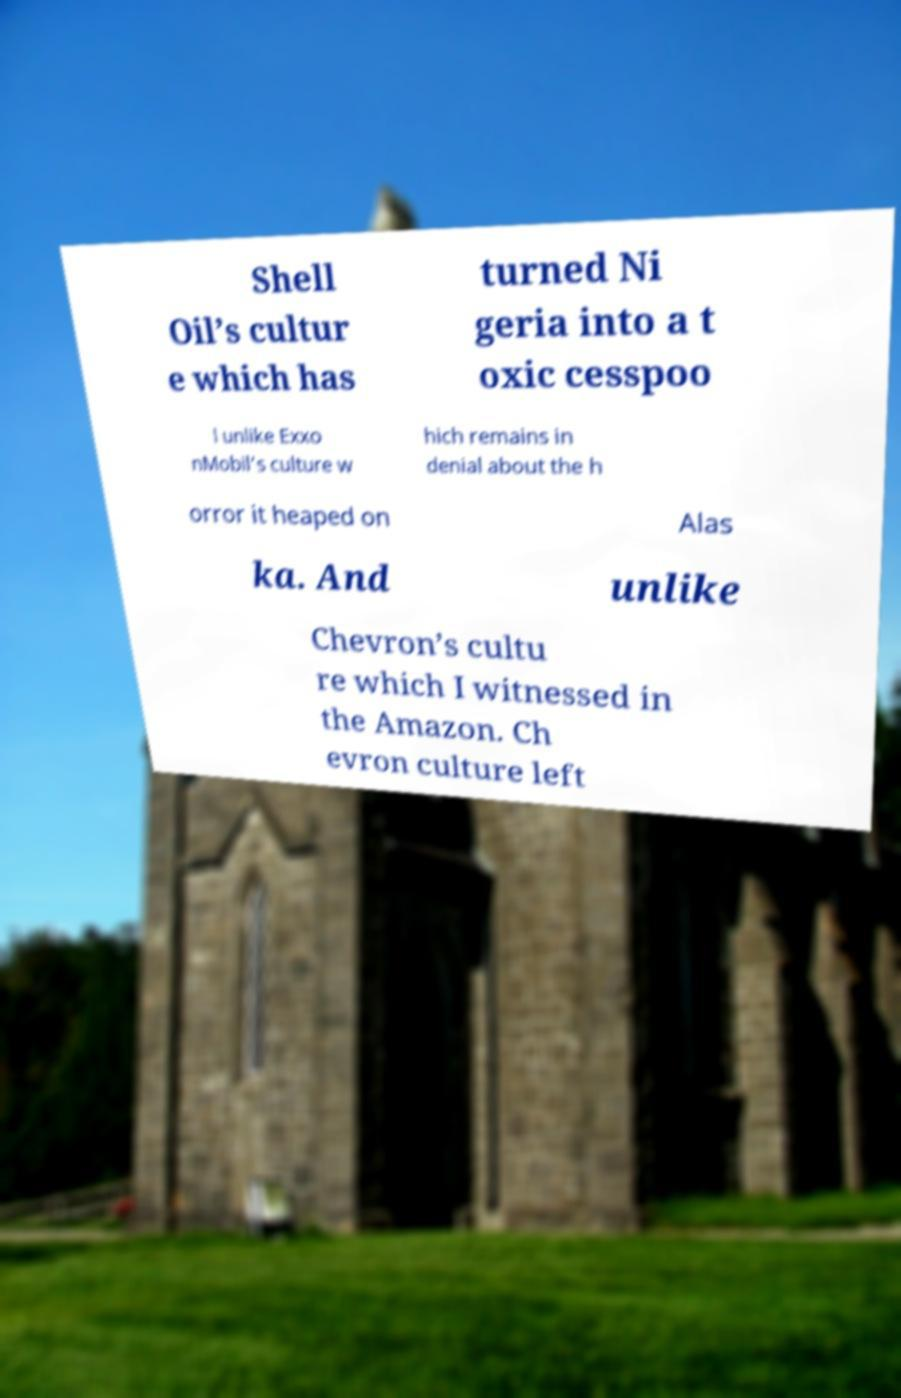Could you extract and type out the text from this image? Shell Oil’s cultur e which has turned Ni geria into a t oxic cesspoo l unlike Exxo nMobil’s culture w hich remains in denial about the h orror it heaped on Alas ka. And unlike Chevron’s cultu re which I witnessed in the Amazon. Ch evron culture left 